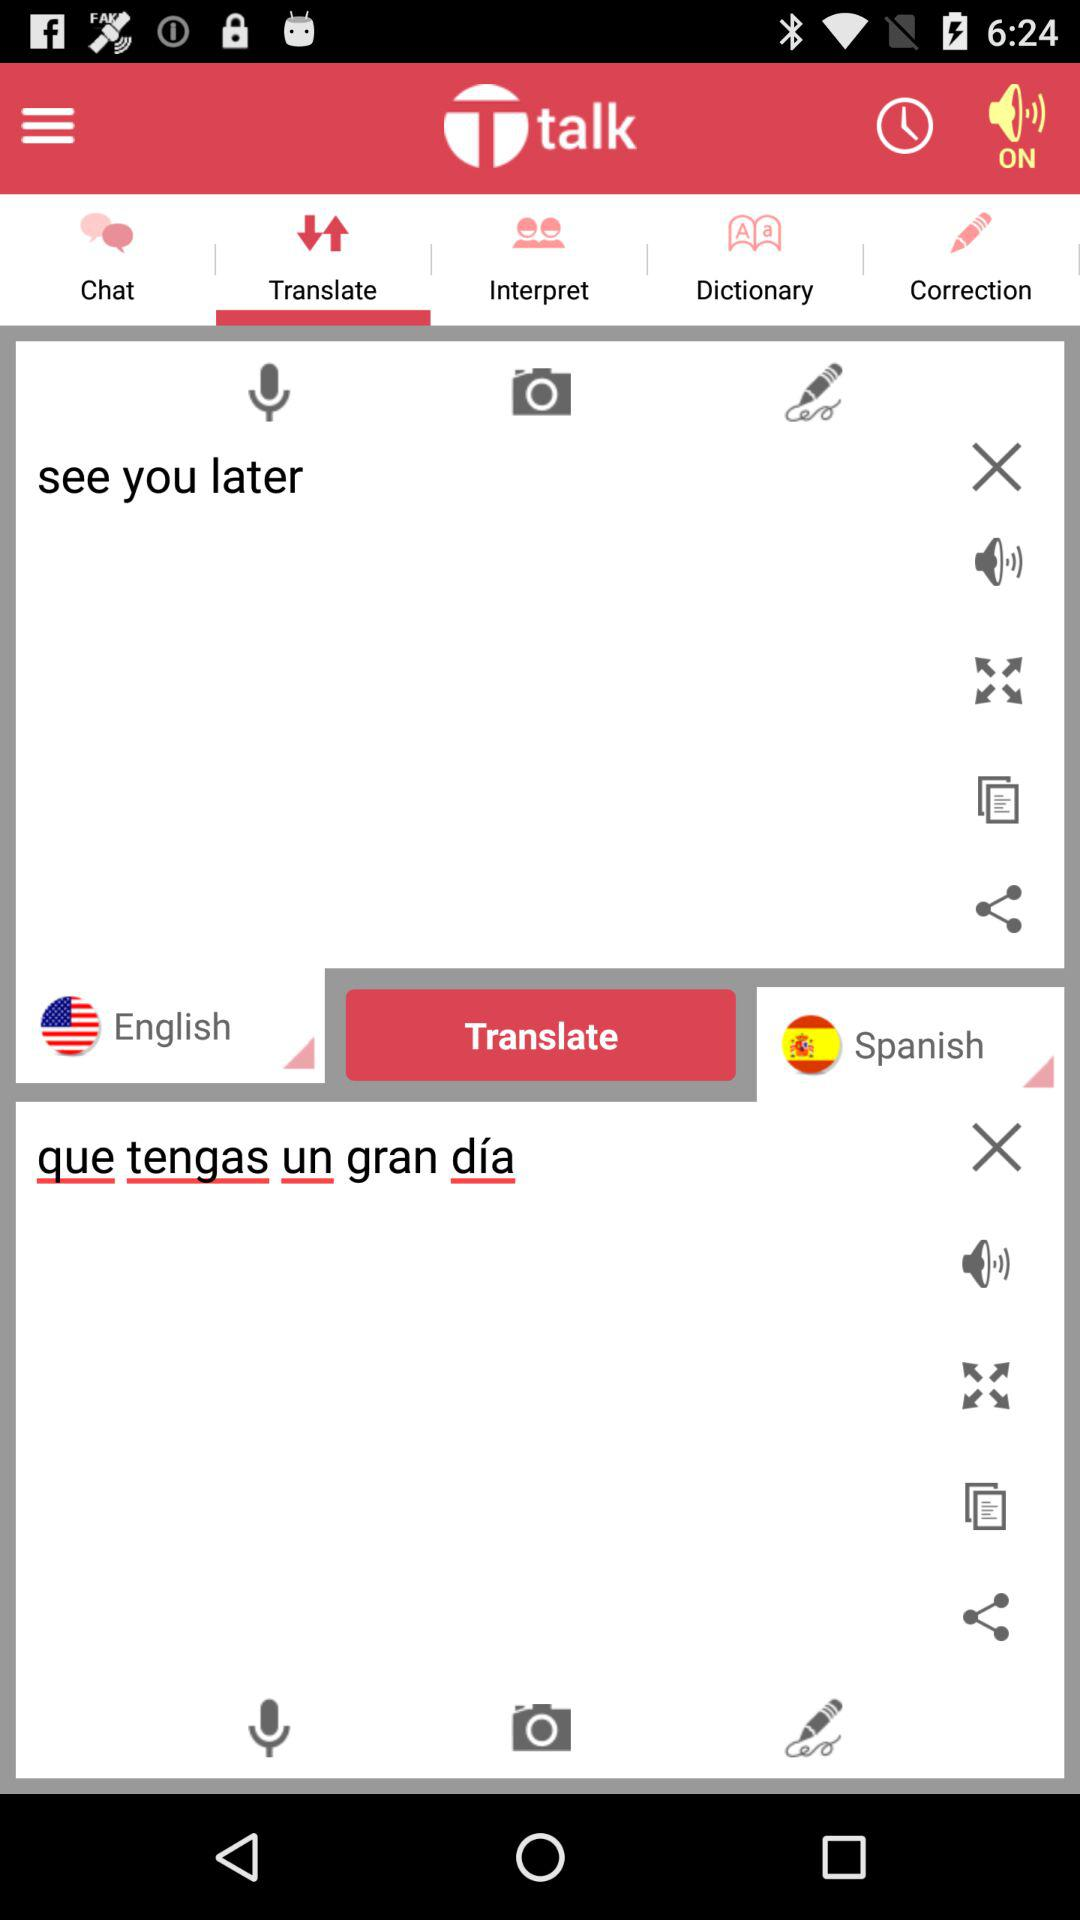What tab is open? The open tab is "Translate". 